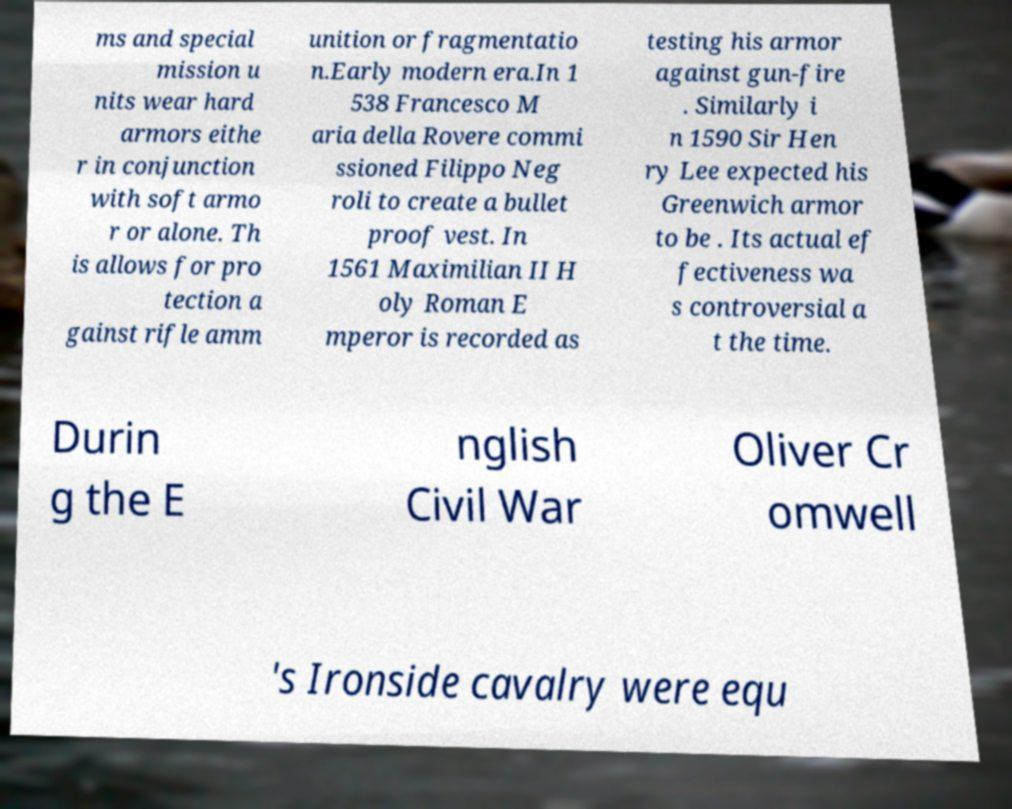Can you accurately transcribe the text from the provided image for me? ms and special mission u nits wear hard armors eithe r in conjunction with soft armo r or alone. Th is allows for pro tection a gainst rifle amm unition or fragmentatio n.Early modern era.In 1 538 Francesco M aria della Rovere commi ssioned Filippo Neg roli to create a bullet proof vest. In 1561 Maximilian II H oly Roman E mperor is recorded as testing his armor against gun-fire . Similarly i n 1590 Sir Hen ry Lee expected his Greenwich armor to be . Its actual ef fectiveness wa s controversial a t the time. Durin g the E nglish Civil War Oliver Cr omwell 's Ironside cavalry were equ 